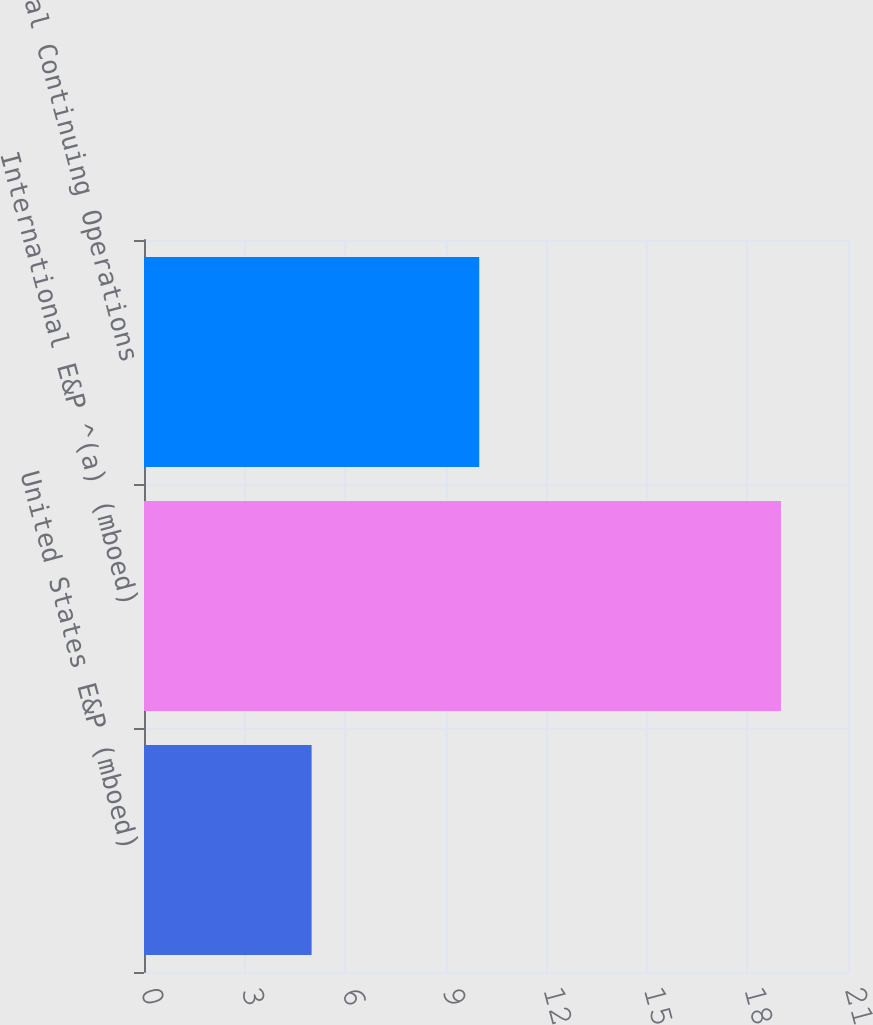Convert chart. <chart><loc_0><loc_0><loc_500><loc_500><bar_chart><fcel>United States E&P (mboed)<fcel>International E&P ^(a) (mboed)<fcel>Total Continuing Operations<nl><fcel>5<fcel>19<fcel>10<nl></chart> 